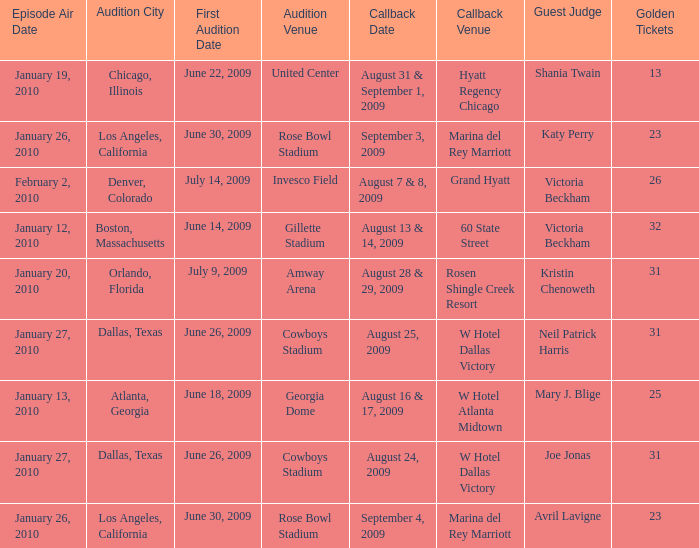Could you parse the entire table as a dict? {'header': ['Episode Air Date', 'Audition City', 'First Audition Date', 'Audition Venue', 'Callback Date', 'Callback Venue', 'Guest Judge', 'Golden Tickets'], 'rows': [['January 19, 2010', 'Chicago, Illinois', 'June 22, 2009', 'United Center', 'August 31 & September 1, 2009', 'Hyatt Regency Chicago', 'Shania Twain', '13'], ['January 26, 2010', 'Los Angeles, California', 'June 30, 2009', 'Rose Bowl Stadium', 'September 3, 2009', 'Marina del Rey Marriott', 'Katy Perry', '23'], ['February 2, 2010', 'Denver, Colorado', 'July 14, 2009', 'Invesco Field', 'August 7 & 8, 2009', 'Grand Hyatt', 'Victoria Beckham', '26'], ['January 12, 2010', 'Boston, Massachusetts', 'June 14, 2009', 'Gillette Stadium', 'August 13 & 14, 2009', '60 State Street', 'Victoria Beckham', '32'], ['January 20, 2010', 'Orlando, Florida', 'July 9, 2009', 'Amway Arena', 'August 28 & 29, 2009', 'Rosen Shingle Creek Resort', 'Kristin Chenoweth', '31'], ['January 27, 2010', 'Dallas, Texas', 'June 26, 2009', 'Cowboys Stadium', 'August 25, 2009', 'W Hotel Dallas Victory', 'Neil Patrick Harris', '31'], ['January 13, 2010', 'Atlanta, Georgia', 'June 18, 2009', 'Georgia Dome', 'August 16 & 17, 2009', 'W Hotel Atlanta Midtown', 'Mary J. Blige', '25'], ['January 27, 2010', 'Dallas, Texas', 'June 26, 2009', 'Cowboys Stadium', 'August 24, 2009', 'W Hotel Dallas Victory', 'Joe Jonas', '31'], ['January 26, 2010', 'Los Angeles, California', 'June 30, 2009', 'Rose Bowl Stadium', 'September 4, 2009', 'Marina del Rey Marriott', 'Avril Lavigne', '23']]} Name the total number of golden tickets being rosen shingle creek resort 1.0. 